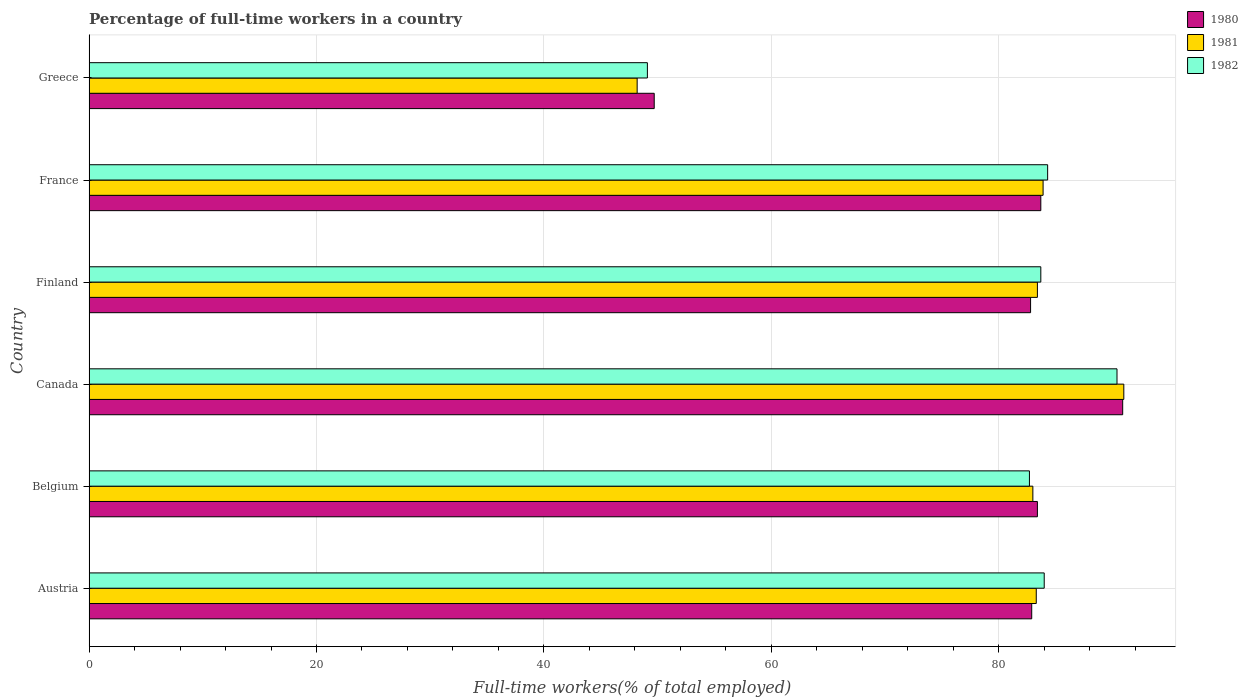How many different coloured bars are there?
Keep it short and to the point. 3. How many groups of bars are there?
Keep it short and to the point. 6. How many bars are there on the 5th tick from the bottom?
Make the answer very short. 3. In how many cases, is the number of bars for a given country not equal to the number of legend labels?
Ensure brevity in your answer.  0. What is the percentage of full-time workers in 1980 in Austria?
Offer a terse response. 82.9. Across all countries, what is the maximum percentage of full-time workers in 1980?
Give a very brief answer. 90.9. Across all countries, what is the minimum percentage of full-time workers in 1980?
Offer a terse response. 49.7. In which country was the percentage of full-time workers in 1981 maximum?
Your answer should be very brief. Canada. In which country was the percentage of full-time workers in 1981 minimum?
Provide a succinct answer. Greece. What is the total percentage of full-time workers in 1982 in the graph?
Provide a short and direct response. 474.2. What is the difference between the percentage of full-time workers in 1982 in Canada and that in Greece?
Your response must be concise. 41.3. What is the difference between the percentage of full-time workers in 1981 in Finland and the percentage of full-time workers in 1980 in Austria?
Provide a succinct answer. 0.5. What is the average percentage of full-time workers in 1980 per country?
Make the answer very short. 78.9. What is the difference between the percentage of full-time workers in 1982 and percentage of full-time workers in 1981 in Finland?
Give a very brief answer. 0.3. What is the ratio of the percentage of full-time workers in 1982 in France to that in Greece?
Your response must be concise. 1.72. Is the percentage of full-time workers in 1980 in Finland less than that in Greece?
Make the answer very short. No. Is the difference between the percentage of full-time workers in 1982 in Belgium and Canada greater than the difference between the percentage of full-time workers in 1981 in Belgium and Canada?
Give a very brief answer. Yes. What is the difference between the highest and the second highest percentage of full-time workers in 1981?
Provide a succinct answer. 7.1. What is the difference between the highest and the lowest percentage of full-time workers in 1981?
Offer a terse response. 42.8. In how many countries, is the percentage of full-time workers in 1982 greater than the average percentage of full-time workers in 1982 taken over all countries?
Your answer should be very brief. 5. What does the 3rd bar from the bottom in Belgium represents?
Provide a short and direct response. 1982. Is it the case that in every country, the sum of the percentage of full-time workers in 1981 and percentage of full-time workers in 1982 is greater than the percentage of full-time workers in 1980?
Your response must be concise. Yes. Are all the bars in the graph horizontal?
Offer a very short reply. Yes. Where does the legend appear in the graph?
Offer a terse response. Top right. How many legend labels are there?
Keep it short and to the point. 3. What is the title of the graph?
Keep it short and to the point. Percentage of full-time workers in a country. Does "1974" appear as one of the legend labels in the graph?
Offer a very short reply. No. What is the label or title of the X-axis?
Provide a short and direct response. Full-time workers(% of total employed). What is the label or title of the Y-axis?
Make the answer very short. Country. What is the Full-time workers(% of total employed) of 1980 in Austria?
Provide a succinct answer. 82.9. What is the Full-time workers(% of total employed) of 1981 in Austria?
Keep it short and to the point. 83.3. What is the Full-time workers(% of total employed) of 1982 in Austria?
Make the answer very short. 84. What is the Full-time workers(% of total employed) of 1980 in Belgium?
Keep it short and to the point. 83.4. What is the Full-time workers(% of total employed) of 1981 in Belgium?
Offer a terse response. 83. What is the Full-time workers(% of total employed) in 1982 in Belgium?
Make the answer very short. 82.7. What is the Full-time workers(% of total employed) in 1980 in Canada?
Keep it short and to the point. 90.9. What is the Full-time workers(% of total employed) in 1981 in Canada?
Keep it short and to the point. 91. What is the Full-time workers(% of total employed) of 1982 in Canada?
Your answer should be compact. 90.4. What is the Full-time workers(% of total employed) in 1980 in Finland?
Offer a terse response. 82.8. What is the Full-time workers(% of total employed) in 1981 in Finland?
Ensure brevity in your answer.  83.4. What is the Full-time workers(% of total employed) of 1982 in Finland?
Provide a succinct answer. 83.7. What is the Full-time workers(% of total employed) of 1980 in France?
Give a very brief answer. 83.7. What is the Full-time workers(% of total employed) of 1981 in France?
Ensure brevity in your answer.  83.9. What is the Full-time workers(% of total employed) in 1982 in France?
Give a very brief answer. 84.3. What is the Full-time workers(% of total employed) of 1980 in Greece?
Make the answer very short. 49.7. What is the Full-time workers(% of total employed) of 1981 in Greece?
Your response must be concise. 48.2. What is the Full-time workers(% of total employed) of 1982 in Greece?
Provide a succinct answer. 49.1. Across all countries, what is the maximum Full-time workers(% of total employed) in 1980?
Give a very brief answer. 90.9. Across all countries, what is the maximum Full-time workers(% of total employed) in 1981?
Make the answer very short. 91. Across all countries, what is the maximum Full-time workers(% of total employed) in 1982?
Make the answer very short. 90.4. Across all countries, what is the minimum Full-time workers(% of total employed) of 1980?
Offer a terse response. 49.7. Across all countries, what is the minimum Full-time workers(% of total employed) of 1981?
Your response must be concise. 48.2. Across all countries, what is the minimum Full-time workers(% of total employed) in 1982?
Keep it short and to the point. 49.1. What is the total Full-time workers(% of total employed) of 1980 in the graph?
Provide a succinct answer. 473.4. What is the total Full-time workers(% of total employed) of 1981 in the graph?
Provide a succinct answer. 472.8. What is the total Full-time workers(% of total employed) in 1982 in the graph?
Your answer should be very brief. 474.2. What is the difference between the Full-time workers(% of total employed) in 1981 in Austria and that in Belgium?
Your response must be concise. 0.3. What is the difference between the Full-time workers(% of total employed) of 1982 in Austria and that in Canada?
Offer a very short reply. -6.4. What is the difference between the Full-time workers(% of total employed) of 1980 in Austria and that in Finland?
Your answer should be compact. 0.1. What is the difference between the Full-time workers(% of total employed) in 1981 in Austria and that in Finland?
Offer a terse response. -0.1. What is the difference between the Full-time workers(% of total employed) in 1982 in Austria and that in Finland?
Offer a terse response. 0.3. What is the difference between the Full-time workers(% of total employed) of 1982 in Austria and that in France?
Your answer should be compact. -0.3. What is the difference between the Full-time workers(% of total employed) in 1980 in Austria and that in Greece?
Your answer should be compact. 33.2. What is the difference between the Full-time workers(% of total employed) in 1981 in Austria and that in Greece?
Offer a terse response. 35.1. What is the difference between the Full-time workers(% of total employed) of 1982 in Austria and that in Greece?
Your response must be concise. 34.9. What is the difference between the Full-time workers(% of total employed) in 1981 in Belgium and that in Canada?
Offer a very short reply. -8. What is the difference between the Full-time workers(% of total employed) in 1982 in Belgium and that in Canada?
Make the answer very short. -7.7. What is the difference between the Full-time workers(% of total employed) in 1980 in Belgium and that in Finland?
Your response must be concise. 0.6. What is the difference between the Full-time workers(% of total employed) of 1980 in Belgium and that in France?
Your response must be concise. -0.3. What is the difference between the Full-time workers(% of total employed) in 1981 in Belgium and that in France?
Offer a very short reply. -0.9. What is the difference between the Full-time workers(% of total employed) in 1982 in Belgium and that in France?
Your response must be concise. -1.6. What is the difference between the Full-time workers(% of total employed) in 1980 in Belgium and that in Greece?
Make the answer very short. 33.7. What is the difference between the Full-time workers(% of total employed) in 1981 in Belgium and that in Greece?
Ensure brevity in your answer.  34.8. What is the difference between the Full-time workers(% of total employed) of 1982 in Belgium and that in Greece?
Offer a terse response. 33.6. What is the difference between the Full-time workers(% of total employed) in 1981 in Canada and that in Finland?
Offer a terse response. 7.6. What is the difference between the Full-time workers(% of total employed) in 1980 in Canada and that in France?
Your answer should be compact. 7.2. What is the difference between the Full-time workers(% of total employed) of 1980 in Canada and that in Greece?
Keep it short and to the point. 41.2. What is the difference between the Full-time workers(% of total employed) in 1981 in Canada and that in Greece?
Your answer should be compact. 42.8. What is the difference between the Full-time workers(% of total employed) in 1982 in Canada and that in Greece?
Offer a very short reply. 41.3. What is the difference between the Full-time workers(% of total employed) of 1980 in Finland and that in France?
Ensure brevity in your answer.  -0.9. What is the difference between the Full-time workers(% of total employed) in 1980 in Finland and that in Greece?
Your answer should be very brief. 33.1. What is the difference between the Full-time workers(% of total employed) of 1981 in Finland and that in Greece?
Your answer should be compact. 35.2. What is the difference between the Full-time workers(% of total employed) of 1982 in Finland and that in Greece?
Give a very brief answer. 34.6. What is the difference between the Full-time workers(% of total employed) of 1981 in France and that in Greece?
Offer a very short reply. 35.7. What is the difference between the Full-time workers(% of total employed) of 1982 in France and that in Greece?
Offer a terse response. 35.2. What is the difference between the Full-time workers(% of total employed) of 1981 in Austria and the Full-time workers(% of total employed) of 1982 in Belgium?
Give a very brief answer. 0.6. What is the difference between the Full-time workers(% of total employed) in 1980 in Austria and the Full-time workers(% of total employed) in 1982 in Finland?
Your response must be concise. -0.8. What is the difference between the Full-time workers(% of total employed) in 1981 in Austria and the Full-time workers(% of total employed) in 1982 in Finland?
Your answer should be compact. -0.4. What is the difference between the Full-time workers(% of total employed) of 1980 in Austria and the Full-time workers(% of total employed) of 1981 in France?
Your answer should be very brief. -1. What is the difference between the Full-time workers(% of total employed) of 1981 in Austria and the Full-time workers(% of total employed) of 1982 in France?
Offer a terse response. -1. What is the difference between the Full-time workers(% of total employed) of 1980 in Austria and the Full-time workers(% of total employed) of 1981 in Greece?
Ensure brevity in your answer.  34.7. What is the difference between the Full-time workers(% of total employed) in 1980 in Austria and the Full-time workers(% of total employed) in 1982 in Greece?
Provide a short and direct response. 33.8. What is the difference between the Full-time workers(% of total employed) in 1981 in Austria and the Full-time workers(% of total employed) in 1982 in Greece?
Ensure brevity in your answer.  34.2. What is the difference between the Full-time workers(% of total employed) of 1981 in Belgium and the Full-time workers(% of total employed) of 1982 in Canada?
Your answer should be compact. -7.4. What is the difference between the Full-time workers(% of total employed) in 1980 in Belgium and the Full-time workers(% of total employed) in 1982 in Finland?
Your response must be concise. -0.3. What is the difference between the Full-time workers(% of total employed) in 1980 in Belgium and the Full-time workers(% of total employed) in 1982 in France?
Make the answer very short. -0.9. What is the difference between the Full-time workers(% of total employed) of 1980 in Belgium and the Full-time workers(% of total employed) of 1981 in Greece?
Offer a very short reply. 35.2. What is the difference between the Full-time workers(% of total employed) of 1980 in Belgium and the Full-time workers(% of total employed) of 1982 in Greece?
Offer a terse response. 34.3. What is the difference between the Full-time workers(% of total employed) in 1981 in Belgium and the Full-time workers(% of total employed) in 1982 in Greece?
Make the answer very short. 33.9. What is the difference between the Full-time workers(% of total employed) of 1980 in Canada and the Full-time workers(% of total employed) of 1981 in Finland?
Ensure brevity in your answer.  7.5. What is the difference between the Full-time workers(% of total employed) of 1980 in Canada and the Full-time workers(% of total employed) of 1982 in Finland?
Your answer should be compact. 7.2. What is the difference between the Full-time workers(% of total employed) in 1980 in Canada and the Full-time workers(% of total employed) in 1981 in France?
Keep it short and to the point. 7. What is the difference between the Full-time workers(% of total employed) in 1981 in Canada and the Full-time workers(% of total employed) in 1982 in France?
Offer a terse response. 6.7. What is the difference between the Full-time workers(% of total employed) in 1980 in Canada and the Full-time workers(% of total employed) in 1981 in Greece?
Keep it short and to the point. 42.7. What is the difference between the Full-time workers(% of total employed) of 1980 in Canada and the Full-time workers(% of total employed) of 1982 in Greece?
Your answer should be compact. 41.8. What is the difference between the Full-time workers(% of total employed) in 1981 in Canada and the Full-time workers(% of total employed) in 1982 in Greece?
Offer a very short reply. 41.9. What is the difference between the Full-time workers(% of total employed) of 1980 in Finland and the Full-time workers(% of total employed) of 1981 in France?
Provide a short and direct response. -1.1. What is the difference between the Full-time workers(% of total employed) in 1981 in Finland and the Full-time workers(% of total employed) in 1982 in France?
Offer a very short reply. -0.9. What is the difference between the Full-time workers(% of total employed) of 1980 in Finland and the Full-time workers(% of total employed) of 1981 in Greece?
Make the answer very short. 34.6. What is the difference between the Full-time workers(% of total employed) of 1980 in Finland and the Full-time workers(% of total employed) of 1982 in Greece?
Your response must be concise. 33.7. What is the difference between the Full-time workers(% of total employed) of 1981 in Finland and the Full-time workers(% of total employed) of 1982 in Greece?
Provide a short and direct response. 34.3. What is the difference between the Full-time workers(% of total employed) in 1980 in France and the Full-time workers(% of total employed) in 1981 in Greece?
Provide a succinct answer. 35.5. What is the difference between the Full-time workers(% of total employed) in 1980 in France and the Full-time workers(% of total employed) in 1982 in Greece?
Your answer should be very brief. 34.6. What is the difference between the Full-time workers(% of total employed) of 1981 in France and the Full-time workers(% of total employed) of 1982 in Greece?
Make the answer very short. 34.8. What is the average Full-time workers(% of total employed) of 1980 per country?
Keep it short and to the point. 78.9. What is the average Full-time workers(% of total employed) of 1981 per country?
Offer a very short reply. 78.8. What is the average Full-time workers(% of total employed) in 1982 per country?
Keep it short and to the point. 79.03. What is the difference between the Full-time workers(% of total employed) of 1980 and Full-time workers(% of total employed) of 1982 in Austria?
Provide a short and direct response. -1.1. What is the difference between the Full-time workers(% of total employed) in 1981 and Full-time workers(% of total employed) in 1982 in Canada?
Make the answer very short. 0.6. What is the difference between the Full-time workers(% of total employed) of 1980 and Full-time workers(% of total employed) of 1982 in Finland?
Make the answer very short. -0.9. What is the difference between the Full-time workers(% of total employed) in 1981 and Full-time workers(% of total employed) in 1982 in Finland?
Provide a succinct answer. -0.3. What is the difference between the Full-time workers(% of total employed) in 1980 and Full-time workers(% of total employed) in 1982 in France?
Give a very brief answer. -0.6. What is the difference between the Full-time workers(% of total employed) in 1980 and Full-time workers(% of total employed) in 1981 in Greece?
Ensure brevity in your answer.  1.5. What is the difference between the Full-time workers(% of total employed) in 1980 and Full-time workers(% of total employed) in 1982 in Greece?
Ensure brevity in your answer.  0.6. What is the difference between the Full-time workers(% of total employed) in 1981 and Full-time workers(% of total employed) in 1982 in Greece?
Give a very brief answer. -0.9. What is the ratio of the Full-time workers(% of total employed) of 1980 in Austria to that in Belgium?
Your response must be concise. 0.99. What is the ratio of the Full-time workers(% of total employed) in 1982 in Austria to that in Belgium?
Your answer should be very brief. 1.02. What is the ratio of the Full-time workers(% of total employed) of 1980 in Austria to that in Canada?
Your answer should be compact. 0.91. What is the ratio of the Full-time workers(% of total employed) in 1981 in Austria to that in Canada?
Provide a short and direct response. 0.92. What is the ratio of the Full-time workers(% of total employed) of 1982 in Austria to that in Canada?
Give a very brief answer. 0.93. What is the ratio of the Full-time workers(% of total employed) of 1981 in Austria to that in Finland?
Offer a very short reply. 1. What is the ratio of the Full-time workers(% of total employed) of 1982 in Austria to that in Finland?
Your answer should be very brief. 1. What is the ratio of the Full-time workers(% of total employed) of 1981 in Austria to that in France?
Ensure brevity in your answer.  0.99. What is the ratio of the Full-time workers(% of total employed) in 1982 in Austria to that in France?
Keep it short and to the point. 1. What is the ratio of the Full-time workers(% of total employed) of 1980 in Austria to that in Greece?
Give a very brief answer. 1.67. What is the ratio of the Full-time workers(% of total employed) of 1981 in Austria to that in Greece?
Offer a very short reply. 1.73. What is the ratio of the Full-time workers(% of total employed) in 1982 in Austria to that in Greece?
Your answer should be very brief. 1.71. What is the ratio of the Full-time workers(% of total employed) in 1980 in Belgium to that in Canada?
Keep it short and to the point. 0.92. What is the ratio of the Full-time workers(% of total employed) in 1981 in Belgium to that in Canada?
Your answer should be very brief. 0.91. What is the ratio of the Full-time workers(% of total employed) in 1982 in Belgium to that in Canada?
Your response must be concise. 0.91. What is the ratio of the Full-time workers(% of total employed) in 1981 in Belgium to that in France?
Offer a terse response. 0.99. What is the ratio of the Full-time workers(% of total employed) of 1980 in Belgium to that in Greece?
Your answer should be very brief. 1.68. What is the ratio of the Full-time workers(% of total employed) of 1981 in Belgium to that in Greece?
Provide a short and direct response. 1.72. What is the ratio of the Full-time workers(% of total employed) in 1982 in Belgium to that in Greece?
Make the answer very short. 1.68. What is the ratio of the Full-time workers(% of total employed) of 1980 in Canada to that in Finland?
Your answer should be compact. 1.1. What is the ratio of the Full-time workers(% of total employed) of 1981 in Canada to that in Finland?
Ensure brevity in your answer.  1.09. What is the ratio of the Full-time workers(% of total employed) of 1980 in Canada to that in France?
Your answer should be compact. 1.09. What is the ratio of the Full-time workers(% of total employed) in 1981 in Canada to that in France?
Provide a succinct answer. 1.08. What is the ratio of the Full-time workers(% of total employed) in 1982 in Canada to that in France?
Ensure brevity in your answer.  1.07. What is the ratio of the Full-time workers(% of total employed) in 1980 in Canada to that in Greece?
Your response must be concise. 1.83. What is the ratio of the Full-time workers(% of total employed) in 1981 in Canada to that in Greece?
Offer a terse response. 1.89. What is the ratio of the Full-time workers(% of total employed) of 1982 in Canada to that in Greece?
Provide a succinct answer. 1.84. What is the ratio of the Full-time workers(% of total employed) of 1980 in Finland to that in France?
Offer a terse response. 0.99. What is the ratio of the Full-time workers(% of total employed) in 1981 in Finland to that in France?
Your response must be concise. 0.99. What is the ratio of the Full-time workers(% of total employed) in 1982 in Finland to that in France?
Provide a short and direct response. 0.99. What is the ratio of the Full-time workers(% of total employed) of 1980 in Finland to that in Greece?
Provide a succinct answer. 1.67. What is the ratio of the Full-time workers(% of total employed) in 1981 in Finland to that in Greece?
Your response must be concise. 1.73. What is the ratio of the Full-time workers(% of total employed) in 1982 in Finland to that in Greece?
Provide a succinct answer. 1.7. What is the ratio of the Full-time workers(% of total employed) in 1980 in France to that in Greece?
Your answer should be compact. 1.68. What is the ratio of the Full-time workers(% of total employed) in 1981 in France to that in Greece?
Your response must be concise. 1.74. What is the ratio of the Full-time workers(% of total employed) of 1982 in France to that in Greece?
Give a very brief answer. 1.72. What is the difference between the highest and the second highest Full-time workers(% of total employed) in 1981?
Ensure brevity in your answer.  7.1. What is the difference between the highest and the lowest Full-time workers(% of total employed) of 1980?
Your answer should be very brief. 41.2. What is the difference between the highest and the lowest Full-time workers(% of total employed) of 1981?
Provide a succinct answer. 42.8. What is the difference between the highest and the lowest Full-time workers(% of total employed) of 1982?
Make the answer very short. 41.3. 